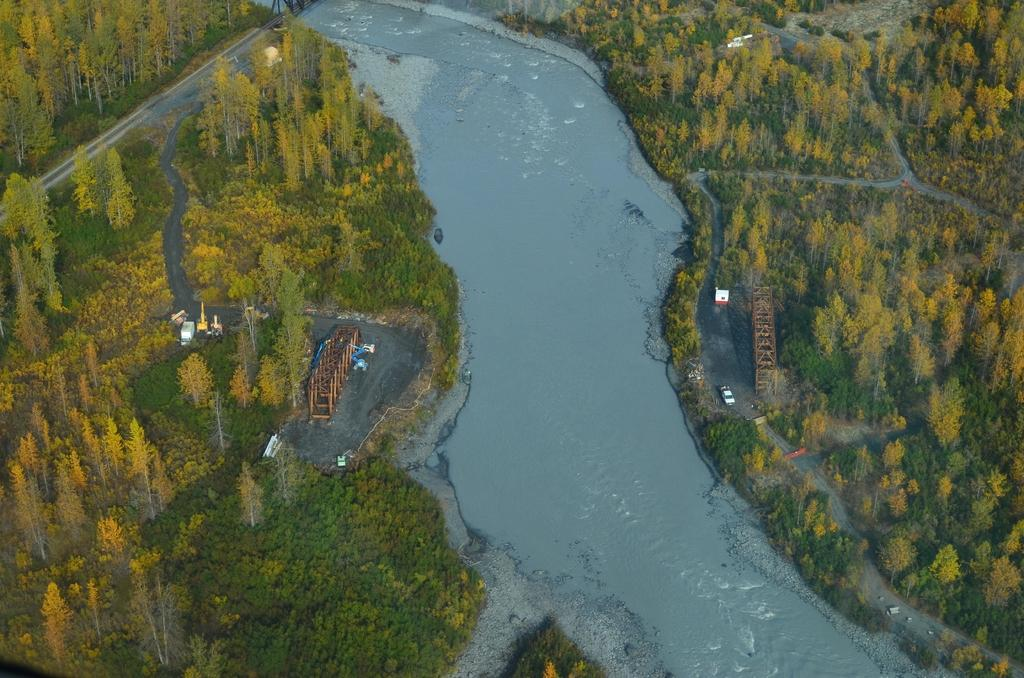What type of view is shown in the image? The image is an aerial view. What can be seen in the center of the image? There is water in the center of the image. Where are the trees located in the image? There are trees on both the left and right sides of the image. What type of coil is visible in the image? There is no coil present in the image. What cable is connecting the trees in the image? There are no cables connecting the trees in the image. 